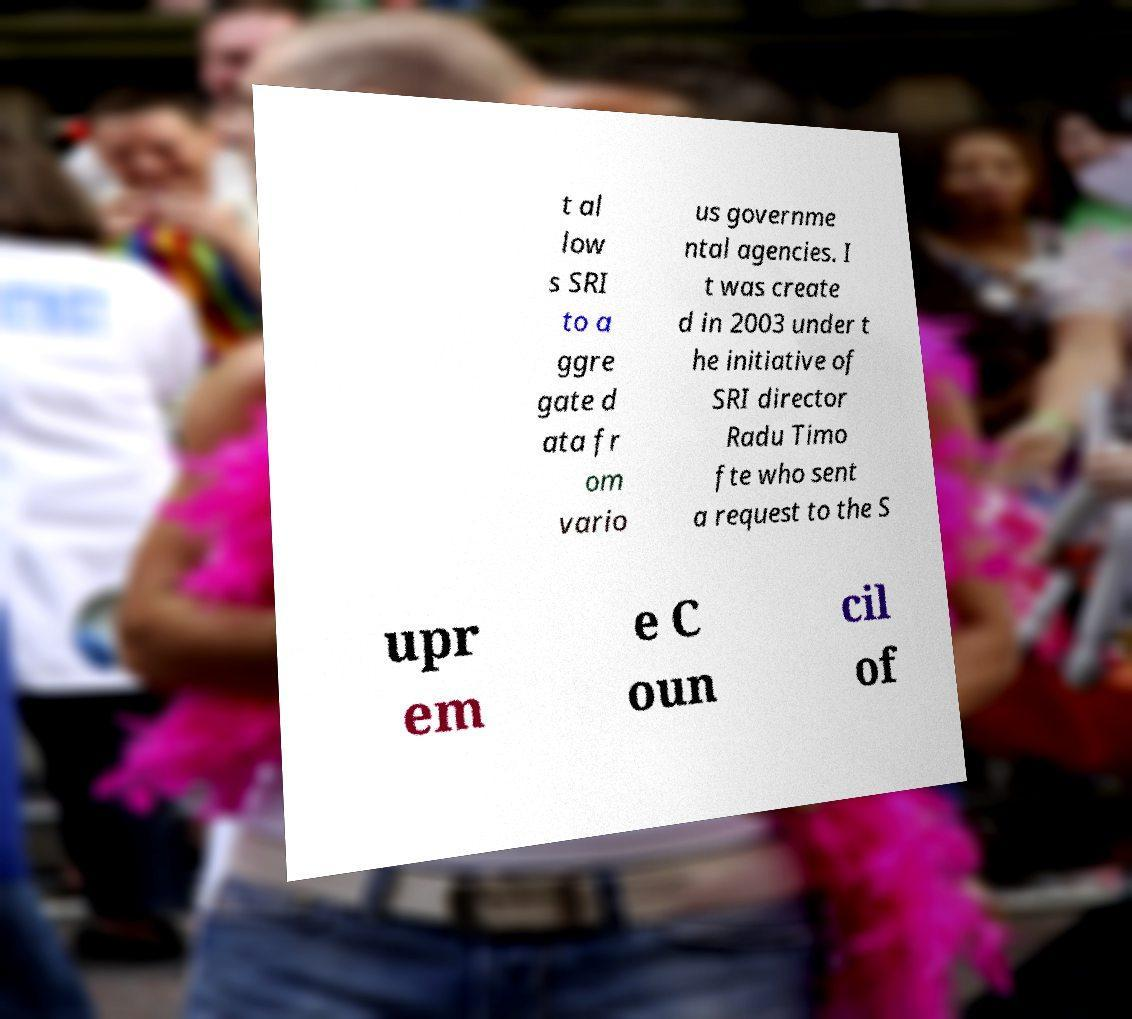What messages or text are displayed in this image? I need them in a readable, typed format. t al low s SRI to a ggre gate d ata fr om vario us governme ntal agencies. I t was create d in 2003 under t he initiative of SRI director Radu Timo fte who sent a request to the S upr em e C oun cil of 